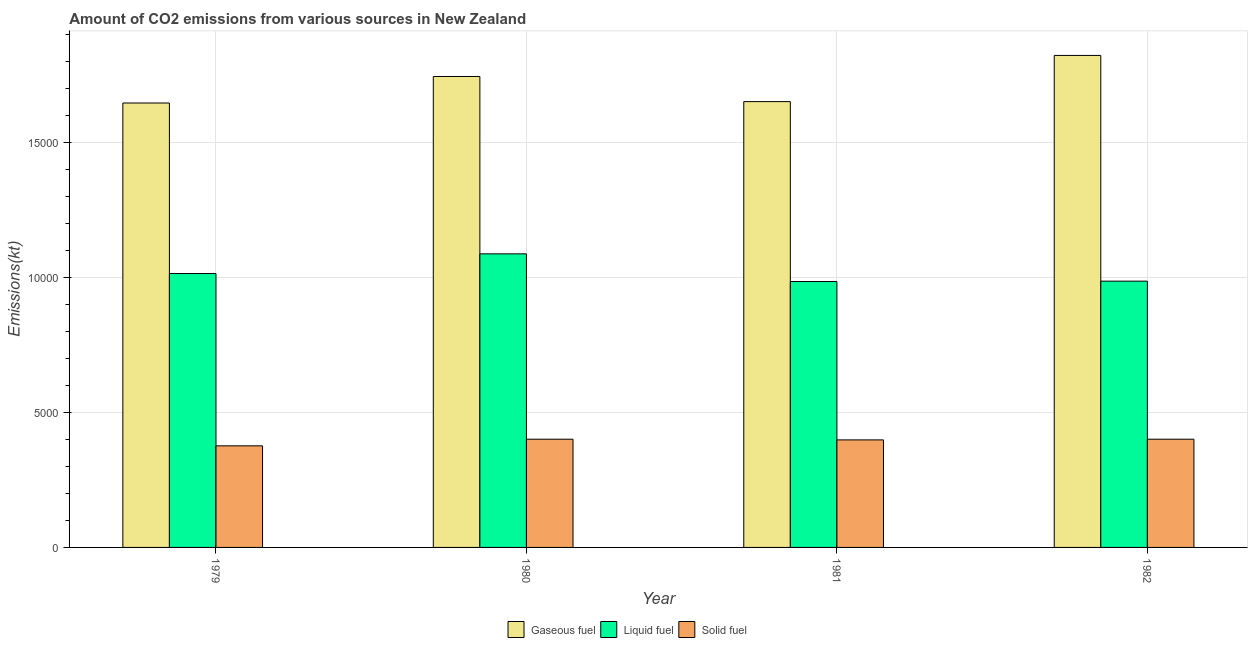How many groups of bars are there?
Keep it short and to the point. 4. How many bars are there on the 2nd tick from the left?
Make the answer very short. 3. How many bars are there on the 3rd tick from the right?
Provide a succinct answer. 3. What is the label of the 4th group of bars from the left?
Give a very brief answer. 1982. In how many cases, is the number of bars for a given year not equal to the number of legend labels?
Provide a succinct answer. 0. What is the amount of co2 emissions from liquid fuel in 1981?
Provide a succinct answer. 9856.9. Across all years, what is the maximum amount of co2 emissions from gaseous fuel?
Your answer should be very brief. 1.82e+04. Across all years, what is the minimum amount of co2 emissions from liquid fuel?
Provide a succinct answer. 9856.9. In which year was the amount of co2 emissions from liquid fuel maximum?
Your response must be concise. 1980. In which year was the amount of co2 emissions from gaseous fuel minimum?
Your answer should be very brief. 1979. What is the total amount of co2 emissions from gaseous fuel in the graph?
Make the answer very short. 6.87e+04. What is the difference between the amount of co2 emissions from solid fuel in 1981 and that in 1982?
Ensure brevity in your answer.  -25.67. What is the difference between the amount of co2 emissions from liquid fuel in 1981 and the amount of co2 emissions from gaseous fuel in 1979?
Ensure brevity in your answer.  -297.03. What is the average amount of co2 emissions from gaseous fuel per year?
Offer a terse response. 1.72e+04. What is the ratio of the amount of co2 emissions from gaseous fuel in 1979 to that in 1981?
Offer a terse response. 1. Is the amount of co2 emissions from liquid fuel in 1980 less than that in 1982?
Your answer should be compact. No. Is the difference between the amount of co2 emissions from solid fuel in 1980 and 1981 greater than the difference between the amount of co2 emissions from liquid fuel in 1980 and 1981?
Keep it short and to the point. No. What is the difference between the highest and the second highest amount of co2 emissions from gaseous fuel?
Provide a succinct answer. 781.07. What is the difference between the highest and the lowest amount of co2 emissions from gaseous fuel?
Provide a succinct answer. 1763.83. In how many years, is the amount of co2 emissions from gaseous fuel greater than the average amount of co2 emissions from gaseous fuel taken over all years?
Your answer should be very brief. 2. What does the 1st bar from the left in 1979 represents?
Provide a short and direct response. Gaseous fuel. What does the 3rd bar from the right in 1982 represents?
Offer a very short reply. Gaseous fuel. How many bars are there?
Give a very brief answer. 12. Are all the bars in the graph horizontal?
Provide a succinct answer. No. What is the difference between two consecutive major ticks on the Y-axis?
Offer a very short reply. 5000. Are the values on the major ticks of Y-axis written in scientific E-notation?
Your answer should be very brief. No. Where does the legend appear in the graph?
Give a very brief answer. Bottom center. How many legend labels are there?
Offer a very short reply. 3. How are the legend labels stacked?
Ensure brevity in your answer.  Horizontal. What is the title of the graph?
Your answer should be compact. Amount of CO2 emissions from various sources in New Zealand. What is the label or title of the Y-axis?
Give a very brief answer. Emissions(kt). What is the Emissions(kt) of Gaseous fuel in 1979?
Offer a very short reply. 1.65e+04. What is the Emissions(kt) in Liquid fuel in 1979?
Your answer should be compact. 1.02e+04. What is the Emissions(kt) of Solid fuel in 1979?
Provide a short and direct response. 3766.01. What is the Emissions(kt) of Gaseous fuel in 1980?
Offer a very short reply. 1.75e+04. What is the Emissions(kt) in Liquid fuel in 1980?
Offer a very short reply. 1.09e+04. What is the Emissions(kt) of Solid fuel in 1980?
Your answer should be compact. 4011.7. What is the Emissions(kt) of Gaseous fuel in 1981?
Offer a terse response. 1.65e+04. What is the Emissions(kt) of Liquid fuel in 1981?
Give a very brief answer. 9856.9. What is the Emissions(kt) of Solid fuel in 1981?
Your answer should be very brief. 3986.03. What is the Emissions(kt) of Gaseous fuel in 1982?
Offer a terse response. 1.82e+04. What is the Emissions(kt) of Liquid fuel in 1982?
Provide a succinct answer. 9871.56. What is the Emissions(kt) in Solid fuel in 1982?
Keep it short and to the point. 4011.7. Across all years, what is the maximum Emissions(kt) of Gaseous fuel?
Keep it short and to the point. 1.82e+04. Across all years, what is the maximum Emissions(kt) of Liquid fuel?
Your answer should be very brief. 1.09e+04. Across all years, what is the maximum Emissions(kt) of Solid fuel?
Provide a succinct answer. 4011.7. Across all years, what is the minimum Emissions(kt) in Gaseous fuel?
Keep it short and to the point. 1.65e+04. Across all years, what is the minimum Emissions(kt) of Liquid fuel?
Your answer should be very brief. 9856.9. Across all years, what is the minimum Emissions(kt) of Solid fuel?
Offer a terse response. 3766.01. What is the total Emissions(kt) in Gaseous fuel in the graph?
Your answer should be very brief. 6.87e+04. What is the total Emissions(kt) in Liquid fuel in the graph?
Offer a terse response. 4.08e+04. What is the total Emissions(kt) of Solid fuel in the graph?
Your answer should be compact. 1.58e+04. What is the difference between the Emissions(kt) in Gaseous fuel in 1979 and that in 1980?
Provide a succinct answer. -982.76. What is the difference between the Emissions(kt) in Liquid fuel in 1979 and that in 1980?
Your answer should be compact. -729.73. What is the difference between the Emissions(kt) of Solid fuel in 1979 and that in 1980?
Your answer should be very brief. -245.69. What is the difference between the Emissions(kt) of Gaseous fuel in 1979 and that in 1981?
Make the answer very short. -51.34. What is the difference between the Emissions(kt) of Liquid fuel in 1979 and that in 1981?
Offer a terse response. 297.03. What is the difference between the Emissions(kt) of Solid fuel in 1979 and that in 1981?
Offer a very short reply. -220.02. What is the difference between the Emissions(kt) of Gaseous fuel in 1979 and that in 1982?
Provide a short and direct response. -1763.83. What is the difference between the Emissions(kt) of Liquid fuel in 1979 and that in 1982?
Your answer should be compact. 282.36. What is the difference between the Emissions(kt) of Solid fuel in 1979 and that in 1982?
Provide a succinct answer. -245.69. What is the difference between the Emissions(kt) in Gaseous fuel in 1980 and that in 1981?
Keep it short and to the point. 931.42. What is the difference between the Emissions(kt) of Liquid fuel in 1980 and that in 1981?
Your response must be concise. 1026.76. What is the difference between the Emissions(kt) of Solid fuel in 1980 and that in 1981?
Ensure brevity in your answer.  25.67. What is the difference between the Emissions(kt) of Gaseous fuel in 1980 and that in 1982?
Offer a terse response. -781.07. What is the difference between the Emissions(kt) in Liquid fuel in 1980 and that in 1982?
Offer a very short reply. 1012.09. What is the difference between the Emissions(kt) in Solid fuel in 1980 and that in 1982?
Keep it short and to the point. 0. What is the difference between the Emissions(kt) of Gaseous fuel in 1981 and that in 1982?
Your answer should be very brief. -1712.49. What is the difference between the Emissions(kt) in Liquid fuel in 1981 and that in 1982?
Give a very brief answer. -14.67. What is the difference between the Emissions(kt) of Solid fuel in 1981 and that in 1982?
Offer a very short reply. -25.67. What is the difference between the Emissions(kt) in Gaseous fuel in 1979 and the Emissions(kt) in Liquid fuel in 1980?
Your response must be concise. 5592.18. What is the difference between the Emissions(kt) of Gaseous fuel in 1979 and the Emissions(kt) of Solid fuel in 1980?
Provide a short and direct response. 1.25e+04. What is the difference between the Emissions(kt) of Liquid fuel in 1979 and the Emissions(kt) of Solid fuel in 1980?
Offer a terse response. 6142.23. What is the difference between the Emissions(kt) in Gaseous fuel in 1979 and the Emissions(kt) in Liquid fuel in 1981?
Your response must be concise. 6618.94. What is the difference between the Emissions(kt) in Gaseous fuel in 1979 and the Emissions(kt) in Solid fuel in 1981?
Keep it short and to the point. 1.25e+04. What is the difference between the Emissions(kt) of Liquid fuel in 1979 and the Emissions(kt) of Solid fuel in 1981?
Offer a very short reply. 6167.89. What is the difference between the Emissions(kt) in Gaseous fuel in 1979 and the Emissions(kt) in Liquid fuel in 1982?
Provide a succinct answer. 6604.27. What is the difference between the Emissions(kt) in Gaseous fuel in 1979 and the Emissions(kt) in Solid fuel in 1982?
Your response must be concise. 1.25e+04. What is the difference between the Emissions(kt) of Liquid fuel in 1979 and the Emissions(kt) of Solid fuel in 1982?
Provide a short and direct response. 6142.23. What is the difference between the Emissions(kt) in Gaseous fuel in 1980 and the Emissions(kt) in Liquid fuel in 1981?
Ensure brevity in your answer.  7601.69. What is the difference between the Emissions(kt) in Gaseous fuel in 1980 and the Emissions(kt) in Solid fuel in 1981?
Make the answer very short. 1.35e+04. What is the difference between the Emissions(kt) in Liquid fuel in 1980 and the Emissions(kt) in Solid fuel in 1981?
Your answer should be very brief. 6897.63. What is the difference between the Emissions(kt) in Gaseous fuel in 1980 and the Emissions(kt) in Liquid fuel in 1982?
Provide a succinct answer. 7587.02. What is the difference between the Emissions(kt) of Gaseous fuel in 1980 and the Emissions(kt) of Solid fuel in 1982?
Give a very brief answer. 1.34e+04. What is the difference between the Emissions(kt) of Liquid fuel in 1980 and the Emissions(kt) of Solid fuel in 1982?
Give a very brief answer. 6871.96. What is the difference between the Emissions(kt) in Gaseous fuel in 1981 and the Emissions(kt) in Liquid fuel in 1982?
Offer a very short reply. 6655.6. What is the difference between the Emissions(kt) of Gaseous fuel in 1981 and the Emissions(kt) of Solid fuel in 1982?
Make the answer very short. 1.25e+04. What is the difference between the Emissions(kt) of Liquid fuel in 1981 and the Emissions(kt) of Solid fuel in 1982?
Keep it short and to the point. 5845.2. What is the average Emissions(kt) of Gaseous fuel per year?
Make the answer very short. 1.72e+04. What is the average Emissions(kt) in Liquid fuel per year?
Keep it short and to the point. 1.02e+04. What is the average Emissions(kt) in Solid fuel per year?
Make the answer very short. 3943.86. In the year 1979, what is the difference between the Emissions(kt) of Gaseous fuel and Emissions(kt) of Liquid fuel?
Ensure brevity in your answer.  6321.91. In the year 1979, what is the difference between the Emissions(kt) of Gaseous fuel and Emissions(kt) of Solid fuel?
Give a very brief answer. 1.27e+04. In the year 1979, what is the difference between the Emissions(kt) in Liquid fuel and Emissions(kt) in Solid fuel?
Your answer should be very brief. 6387.91. In the year 1980, what is the difference between the Emissions(kt) of Gaseous fuel and Emissions(kt) of Liquid fuel?
Ensure brevity in your answer.  6574.93. In the year 1980, what is the difference between the Emissions(kt) of Gaseous fuel and Emissions(kt) of Solid fuel?
Provide a short and direct response. 1.34e+04. In the year 1980, what is the difference between the Emissions(kt) in Liquid fuel and Emissions(kt) in Solid fuel?
Provide a succinct answer. 6871.96. In the year 1981, what is the difference between the Emissions(kt) in Gaseous fuel and Emissions(kt) in Liquid fuel?
Provide a succinct answer. 6670.27. In the year 1981, what is the difference between the Emissions(kt) in Gaseous fuel and Emissions(kt) in Solid fuel?
Provide a succinct answer. 1.25e+04. In the year 1981, what is the difference between the Emissions(kt) of Liquid fuel and Emissions(kt) of Solid fuel?
Provide a short and direct response. 5870.87. In the year 1982, what is the difference between the Emissions(kt) of Gaseous fuel and Emissions(kt) of Liquid fuel?
Provide a succinct answer. 8368.09. In the year 1982, what is the difference between the Emissions(kt) in Gaseous fuel and Emissions(kt) in Solid fuel?
Provide a short and direct response. 1.42e+04. In the year 1982, what is the difference between the Emissions(kt) of Liquid fuel and Emissions(kt) of Solid fuel?
Your response must be concise. 5859.87. What is the ratio of the Emissions(kt) in Gaseous fuel in 1979 to that in 1980?
Make the answer very short. 0.94. What is the ratio of the Emissions(kt) in Liquid fuel in 1979 to that in 1980?
Your response must be concise. 0.93. What is the ratio of the Emissions(kt) of Solid fuel in 1979 to that in 1980?
Make the answer very short. 0.94. What is the ratio of the Emissions(kt) in Gaseous fuel in 1979 to that in 1981?
Make the answer very short. 1. What is the ratio of the Emissions(kt) in Liquid fuel in 1979 to that in 1981?
Make the answer very short. 1.03. What is the ratio of the Emissions(kt) of Solid fuel in 1979 to that in 1981?
Your answer should be compact. 0.94. What is the ratio of the Emissions(kt) in Gaseous fuel in 1979 to that in 1982?
Your answer should be compact. 0.9. What is the ratio of the Emissions(kt) in Liquid fuel in 1979 to that in 1982?
Your answer should be compact. 1.03. What is the ratio of the Emissions(kt) of Solid fuel in 1979 to that in 1982?
Your response must be concise. 0.94. What is the ratio of the Emissions(kt) in Gaseous fuel in 1980 to that in 1981?
Your answer should be compact. 1.06. What is the ratio of the Emissions(kt) in Liquid fuel in 1980 to that in 1981?
Provide a short and direct response. 1.1. What is the ratio of the Emissions(kt) of Solid fuel in 1980 to that in 1981?
Make the answer very short. 1.01. What is the ratio of the Emissions(kt) of Gaseous fuel in 1980 to that in 1982?
Your answer should be compact. 0.96. What is the ratio of the Emissions(kt) in Liquid fuel in 1980 to that in 1982?
Ensure brevity in your answer.  1.1. What is the ratio of the Emissions(kt) of Gaseous fuel in 1981 to that in 1982?
Your response must be concise. 0.91. What is the ratio of the Emissions(kt) of Liquid fuel in 1981 to that in 1982?
Ensure brevity in your answer.  1. What is the ratio of the Emissions(kt) in Solid fuel in 1981 to that in 1982?
Your response must be concise. 0.99. What is the difference between the highest and the second highest Emissions(kt) of Gaseous fuel?
Offer a terse response. 781.07. What is the difference between the highest and the second highest Emissions(kt) in Liquid fuel?
Offer a terse response. 729.73. What is the difference between the highest and the lowest Emissions(kt) of Gaseous fuel?
Provide a succinct answer. 1763.83. What is the difference between the highest and the lowest Emissions(kt) in Liquid fuel?
Offer a terse response. 1026.76. What is the difference between the highest and the lowest Emissions(kt) in Solid fuel?
Keep it short and to the point. 245.69. 